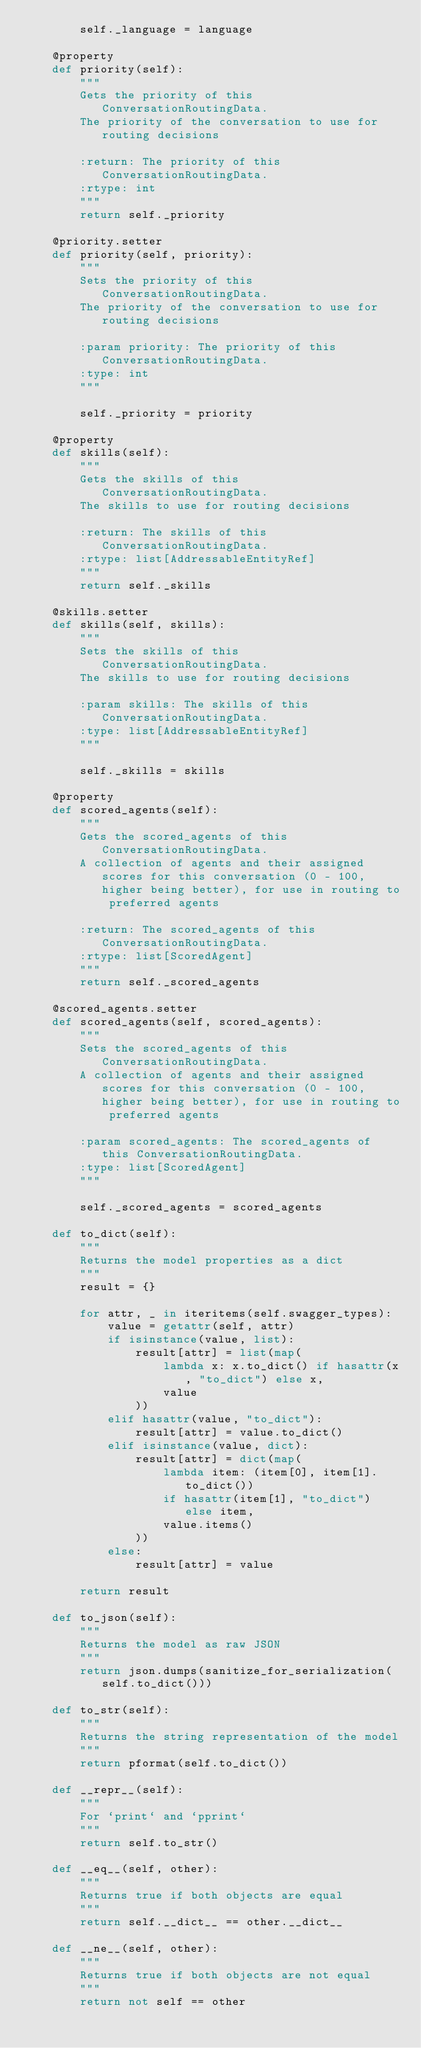Convert code to text. <code><loc_0><loc_0><loc_500><loc_500><_Python_>        self._language = language

    @property
    def priority(self):
        """
        Gets the priority of this ConversationRoutingData.
        The priority of the conversation to use for routing decisions

        :return: The priority of this ConversationRoutingData.
        :rtype: int
        """
        return self._priority

    @priority.setter
    def priority(self, priority):
        """
        Sets the priority of this ConversationRoutingData.
        The priority of the conversation to use for routing decisions

        :param priority: The priority of this ConversationRoutingData.
        :type: int
        """
        
        self._priority = priority

    @property
    def skills(self):
        """
        Gets the skills of this ConversationRoutingData.
        The skills to use for routing decisions

        :return: The skills of this ConversationRoutingData.
        :rtype: list[AddressableEntityRef]
        """
        return self._skills

    @skills.setter
    def skills(self, skills):
        """
        Sets the skills of this ConversationRoutingData.
        The skills to use for routing decisions

        :param skills: The skills of this ConversationRoutingData.
        :type: list[AddressableEntityRef]
        """
        
        self._skills = skills

    @property
    def scored_agents(self):
        """
        Gets the scored_agents of this ConversationRoutingData.
        A collection of agents and their assigned scores for this conversation (0 - 100, higher being better), for use in routing to preferred agents

        :return: The scored_agents of this ConversationRoutingData.
        :rtype: list[ScoredAgent]
        """
        return self._scored_agents

    @scored_agents.setter
    def scored_agents(self, scored_agents):
        """
        Sets the scored_agents of this ConversationRoutingData.
        A collection of agents and their assigned scores for this conversation (0 - 100, higher being better), for use in routing to preferred agents

        :param scored_agents: The scored_agents of this ConversationRoutingData.
        :type: list[ScoredAgent]
        """
        
        self._scored_agents = scored_agents

    def to_dict(self):
        """
        Returns the model properties as a dict
        """
        result = {}

        for attr, _ in iteritems(self.swagger_types):
            value = getattr(self, attr)
            if isinstance(value, list):
                result[attr] = list(map(
                    lambda x: x.to_dict() if hasattr(x, "to_dict") else x,
                    value
                ))
            elif hasattr(value, "to_dict"):
                result[attr] = value.to_dict()
            elif isinstance(value, dict):
                result[attr] = dict(map(
                    lambda item: (item[0], item[1].to_dict())
                    if hasattr(item[1], "to_dict") else item,
                    value.items()
                ))
            else:
                result[attr] = value

        return result

    def to_json(self):
        """
        Returns the model as raw JSON
        """
        return json.dumps(sanitize_for_serialization(self.to_dict()))

    def to_str(self):
        """
        Returns the string representation of the model
        """
        return pformat(self.to_dict())

    def __repr__(self):
        """
        For `print` and `pprint`
        """
        return self.to_str()

    def __eq__(self, other):
        """
        Returns true if both objects are equal
        """
        return self.__dict__ == other.__dict__

    def __ne__(self, other):
        """
        Returns true if both objects are not equal
        """
        return not self == other

</code> 